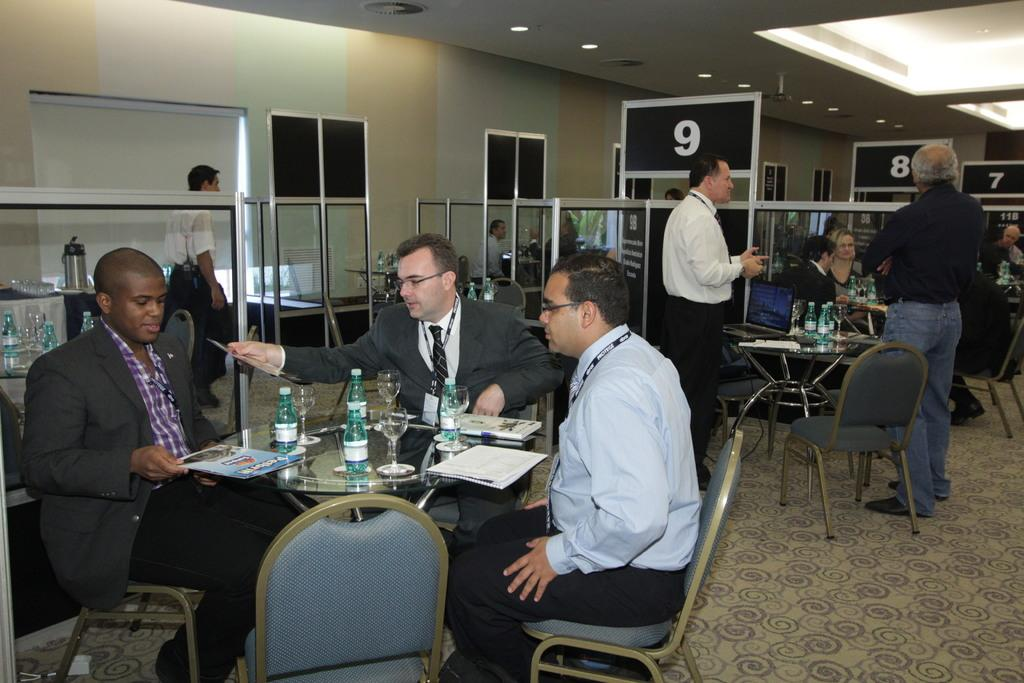What is present in the image that serves as a backdrop or boundary? There is a wall in the image. What are the people in the image doing? The people in the image are standing and sitting. What type of furniture is visible in the image? There are chairs and tables in the image. What items can be seen on the tables? There are books, papers, glasses, and bottles on the tables. What type of store is depicted in the image? There is no store present in the image; it features a wall, people, chairs, tables, and various items on the tables. What muscle is being exercised by the people in the image? There is no indication of any physical activity or muscle engagement in the image. 